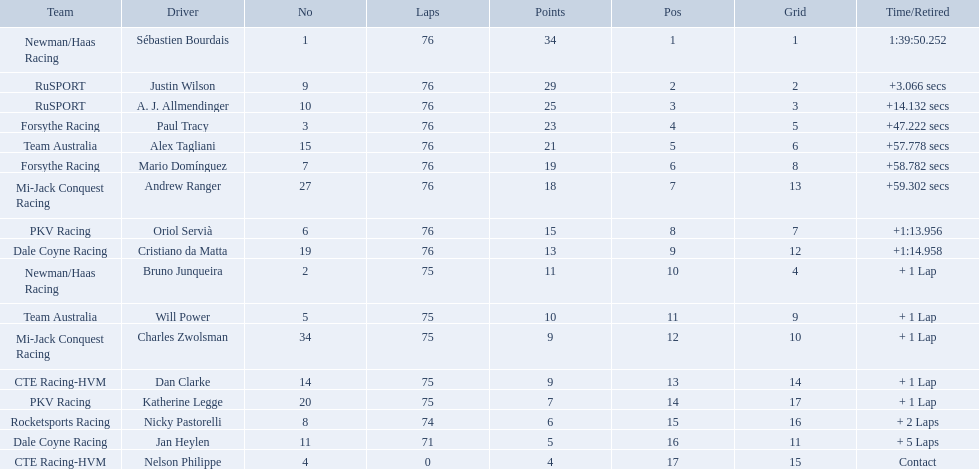Who drove during the 2006 tecate grand prix of monterrey? Sébastien Bourdais, Justin Wilson, A. J. Allmendinger, Paul Tracy, Alex Tagliani, Mario Domínguez, Andrew Ranger, Oriol Servià, Cristiano da Matta, Bruno Junqueira, Will Power, Charles Zwolsman, Dan Clarke, Katherine Legge, Nicky Pastorelli, Jan Heylen, Nelson Philippe. And what were their finishing positions? 1, 2, 3, 4, 5, 6, 7, 8, 9, 10, 11, 12, 13, 14, 15, 16, 17. Who did alex tagliani finish directly behind of? Paul Tracy. 